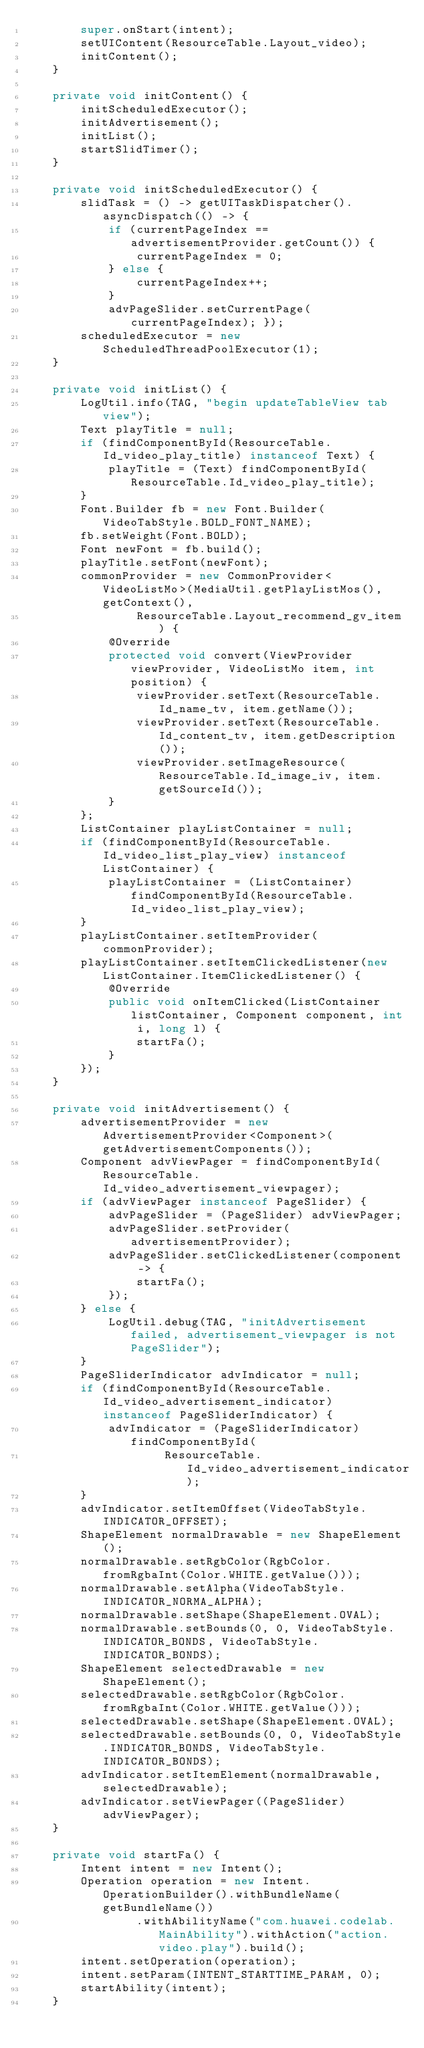Convert code to text. <code><loc_0><loc_0><loc_500><loc_500><_Java_>        super.onStart(intent);
        setUIContent(ResourceTable.Layout_video);
        initContent();
    }

    private void initContent() {
        initScheduledExecutor();
        initAdvertisement();
        initList();
        startSlidTimer();
    }

    private void initScheduledExecutor() {
        slidTask = () -> getUITaskDispatcher().asyncDispatch(() -> {
            if (currentPageIndex == advertisementProvider.getCount()) {
                currentPageIndex = 0;
            } else {
                currentPageIndex++;
            }
            advPageSlider.setCurrentPage(currentPageIndex); });
        scheduledExecutor = new ScheduledThreadPoolExecutor(1);
    }

    private void initList() {
        LogUtil.info(TAG, "begin updateTableView tab view");
        Text playTitle = null;
        if (findComponentById(ResourceTable.Id_video_play_title) instanceof Text) {
            playTitle = (Text) findComponentById(ResourceTable.Id_video_play_title);
        }
        Font.Builder fb = new Font.Builder(VideoTabStyle.BOLD_FONT_NAME);
        fb.setWeight(Font.BOLD);
        Font newFont = fb.build();
        playTitle.setFont(newFont);
        commonProvider = new CommonProvider<VideoListMo>(MediaUtil.getPlayListMos(), getContext(),
                ResourceTable.Layout_recommend_gv_item) {
            @Override
            protected void convert(ViewProvider viewProvider, VideoListMo item, int position) {
                viewProvider.setText(ResourceTable.Id_name_tv, item.getName());
                viewProvider.setText(ResourceTable.Id_content_tv, item.getDescription());
                viewProvider.setImageResource(ResourceTable.Id_image_iv, item.getSourceId());
            }
        };
        ListContainer playListContainer = null;
        if (findComponentById(ResourceTable.Id_video_list_play_view) instanceof ListContainer) {
            playListContainer = (ListContainer) findComponentById(ResourceTable.Id_video_list_play_view);
        }
        playListContainer.setItemProvider(commonProvider);
        playListContainer.setItemClickedListener(new ListContainer.ItemClickedListener() {
            @Override
            public void onItemClicked(ListContainer listContainer, Component component, int i, long l) {
                startFa();
            }
        });
    }

    private void initAdvertisement() {
        advertisementProvider = new AdvertisementProvider<Component>(getAdvertisementComponents());
        Component advViewPager = findComponentById(ResourceTable.Id_video_advertisement_viewpager);
        if (advViewPager instanceof PageSlider) {
            advPageSlider = (PageSlider) advViewPager;
            advPageSlider.setProvider(advertisementProvider);
            advPageSlider.setClickedListener(component -> {
                startFa();
            });
        } else {
            LogUtil.debug(TAG, "initAdvertisement failed, advertisement_viewpager is not PageSlider");
        }
        PageSliderIndicator advIndicator = null;
        if (findComponentById(ResourceTable.Id_video_advertisement_indicator) instanceof PageSliderIndicator) {
            advIndicator = (PageSliderIndicator) findComponentById(
                    ResourceTable.Id_video_advertisement_indicator);
        }
        advIndicator.setItemOffset(VideoTabStyle.INDICATOR_OFFSET);
        ShapeElement normalDrawable = new ShapeElement();
        normalDrawable.setRgbColor(RgbColor.fromRgbaInt(Color.WHITE.getValue()));
        normalDrawable.setAlpha(VideoTabStyle.INDICATOR_NORMA_ALPHA);
        normalDrawable.setShape(ShapeElement.OVAL);
        normalDrawable.setBounds(0, 0, VideoTabStyle.INDICATOR_BONDS, VideoTabStyle.INDICATOR_BONDS);
        ShapeElement selectedDrawable = new ShapeElement();
        selectedDrawable.setRgbColor(RgbColor.fromRgbaInt(Color.WHITE.getValue()));
        selectedDrawable.setShape(ShapeElement.OVAL);
        selectedDrawable.setBounds(0, 0, VideoTabStyle.INDICATOR_BONDS, VideoTabStyle.INDICATOR_BONDS);
        advIndicator.setItemElement(normalDrawable, selectedDrawable);
        advIndicator.setViewPager((PageSlider) advViewPager);
    }

    private void startFa() {
        Intent intent = new Intent();
        Operation operation = new Intent.OperationBuilder().withBundleName(getBundleName())
                .withAbilityName("com.huawei.codelab.MainAbility").withAction("action.video.play").build();
        intent.setOperation(operation);
        intent.setParam(INTENT_STARTTIME_PARAM, 0);
        startAbility(intent);
    }
</code> 